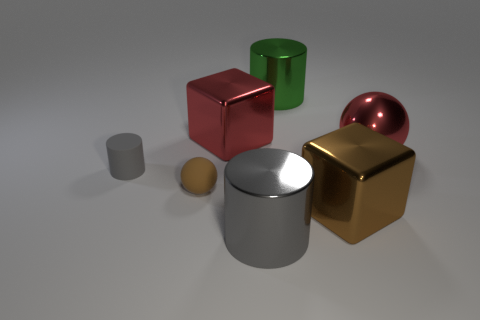Subtract all gray cylinders. How many cylinders are left? 1 Subtract all gray balls. How many gray cylinders are left? 2 Add 1 green balls. How many objects exist? 8 Subtract all green cylinders. How many cylinders are left? 2 Subtract all balls. How many objects are left? 5 Subtract all big cylinders. Subtract all metal cylinders. How many objects are left? 3 Add 7 large red things. How many large red things are left? 9 Add 1 cyan matte objects. How many cyan matte objects exist? 1 Subtract 0 blue cubes. How many objects are left? 7 Subtract all yellow cylinders. Subtract all brown spheres. How many cylinders are left? 3 